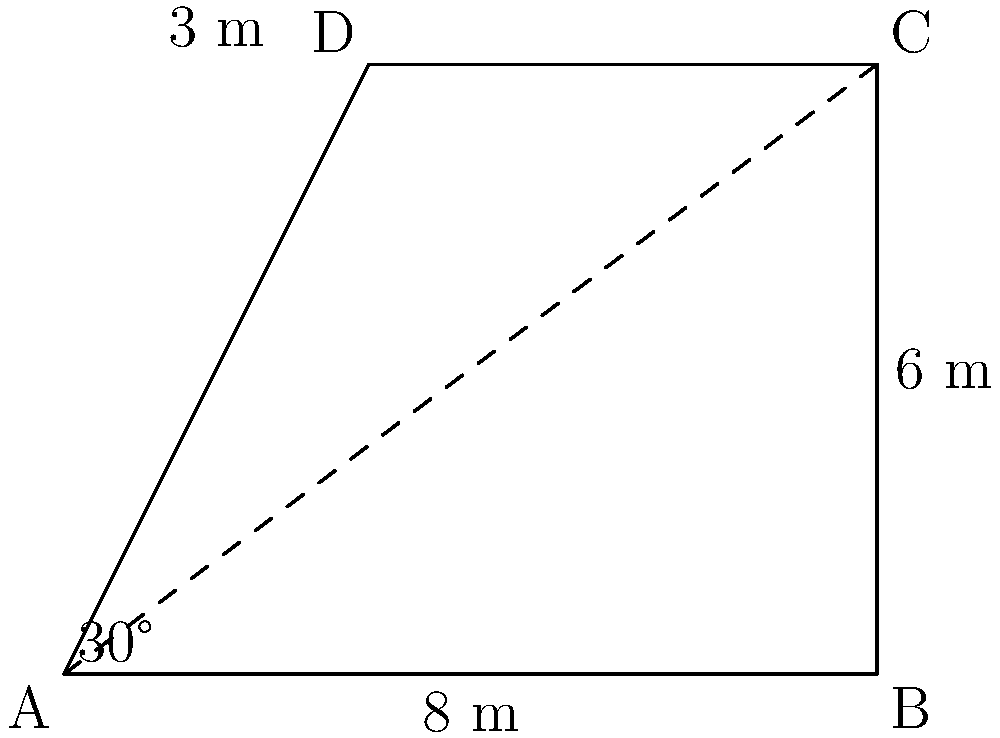As part of designing an outdoor therapy space for incarcerated individuals, you need to estimate the area of an irregularly shaped plot. The plot is represented by quadrilateral ABCD in the diagram. Given that angle BAC is 30°, AB is 8 meters, BC is 6 meters, and CD is 3 meters, calculate the approximate area of the outdoor therapy space. To solve this problem, we'll divide the quadrilateral into two triangles and calculate their areas separately:

1. For triangle ABC:
   - We know the base (AB) = 8 m and the height (BC) = 6 m
   - Area of triangle ABC = $\frac{1}{2} \times base \times height = \frac{1}{2} \times 8 \times 6 = 24$ m²

2. For triangle ACD:
   - We know AC (hypotenuse of triangle ABC)
   - AC = $\frac{8}{\cos 30°} = \frac{8}{\frac{\sqrt{3}}{2}} = \frac{8\sqrt{3}}{3} \approx 9.24$ m
   - Now we can use Heron's formula to calculate the area of triangle ACD
   - Semi-perimeter s = $\frac{AC + CD + AD}{2}$
   - AD = $\sqrt{3^2 + 3^2} = 3\sqrt{2} \approx 4.24$ m
   - s = $\frac{9.24 + 3 + 4.24}{2} \approx 8.24$ m
   - Area of triangle ACD = $\sqrt{s(s-AC)(s-CD)(s-AD)}$
   - Area of triangle ACD ≈ $\sqrt{8.24(8.24-9.24)(8.24-3)(8.24-4.24)} \approx 6.36$ m²

3. Total area of quadrilateral ABCD:
   Area = Area of triangle ABC + Area of triangle ACD
   Area ≈ 24 + 6.36 = 30.36 m²

Therefore, the approximate area of the outdoor therapy space is 30.36 square meters.
Answer: 30.36 m² 